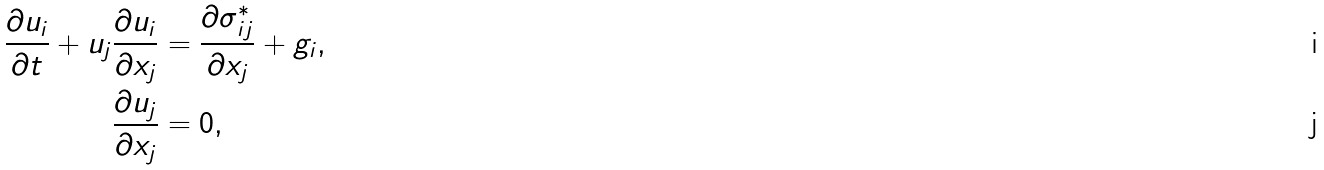<formula> <loc_0><loc_0><loc_500><loc_500>\frac { \partial u _ { i } } { \partial t } + u _ { j } \frac { \partial u _ { i } } { \partial x _ { j } } & = \frac { \partial \sigma _ { i j } ^ { * } } { \partial x _ { j } } + g _ { i } , \\ \frac { \partial u _ { j } } { \partial x _ { j } } & = 0 ,</formula> 